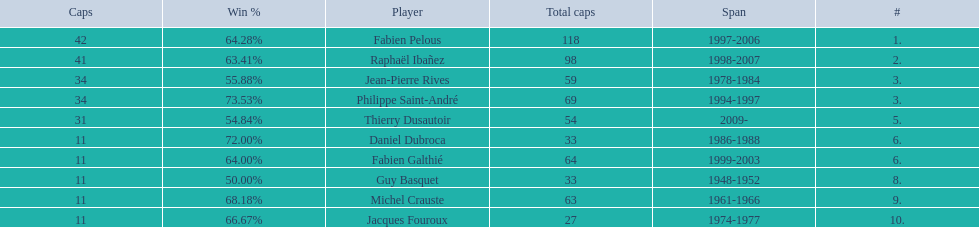Which captain served the least amount of time? Daniel Dubroca. 